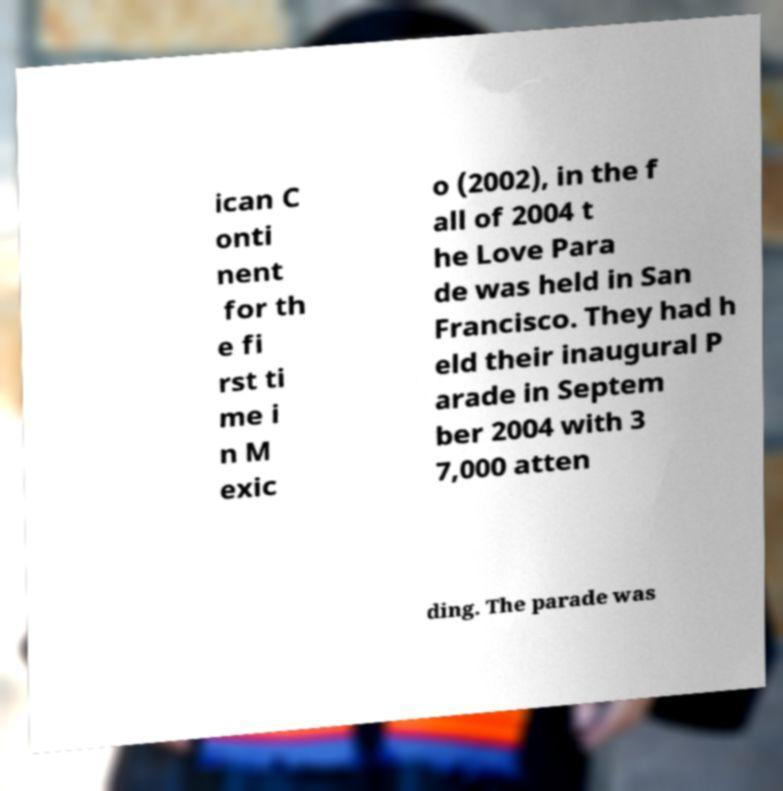Please identify and transcribe the text found in this image. ican C onti nent for th e fi rst ti me i n M exic o (2002), in the f all of 2004 t he Love Para de was held in San Francisco. They had h eld their inaugural P arade in Septem ber 2004 with 3 7,000 atten ding. The parade was 